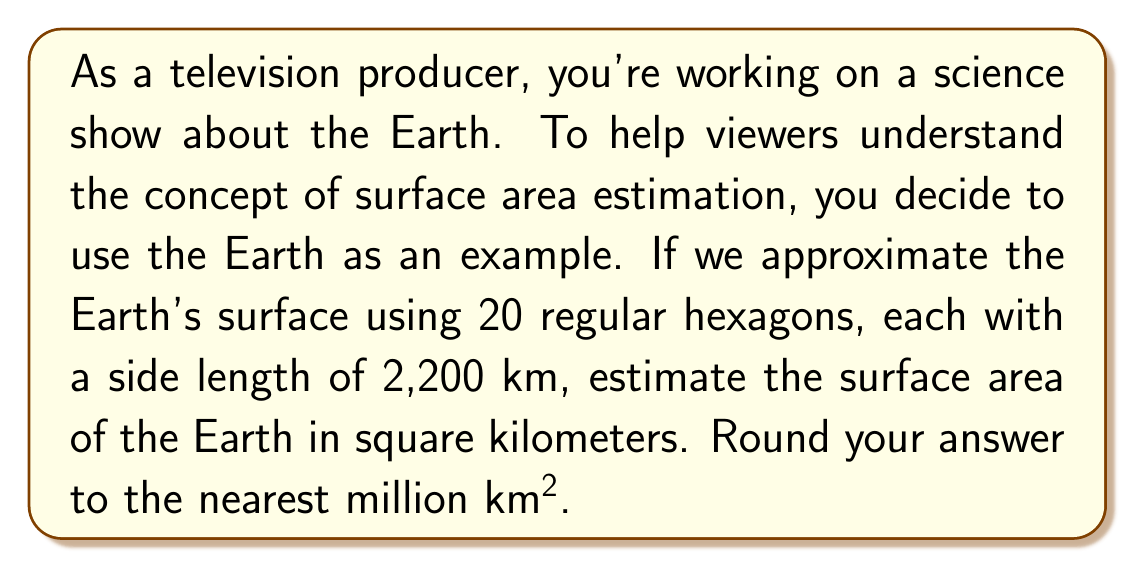Help me with this question. Let's break this down into steps:

1) First, we need to calculate the area of a single hexagon. The formula for the area of a regular hexagon is:

   $$A = \frac{3\sqrt{3}}{2}s^2$$

   where $s$ is the side length.

2) Substituting $s = 2,200$ km:

   $$A = \frac{3\sqrt{3}}{2}(2,200)^2 = 11,977,580.08 \text{ km}^2$$

3) We're using 20 of these hexagons to approximate the Earth's surface, so we multiply this area by 20:

   $$20 \times 11,977,580.08 = 239,551,601.6 \text{ km}^2$$

4) Rounding to the nearest million km²:

   $$239,551,601.6 \text{ km}^2 \approx 240,000,000 \text{ km}^2$$

This estimation method gives us an approximation of the Earth's surface area. For comparison, the actual surface area of the Earth is about 510 million km². Our estimate is lower because the planar hexagons don't account for the Earth's curvature, demonstrating the limitations of using planar shapes to estimate curved surfaces.
Answer: 240 million km² 